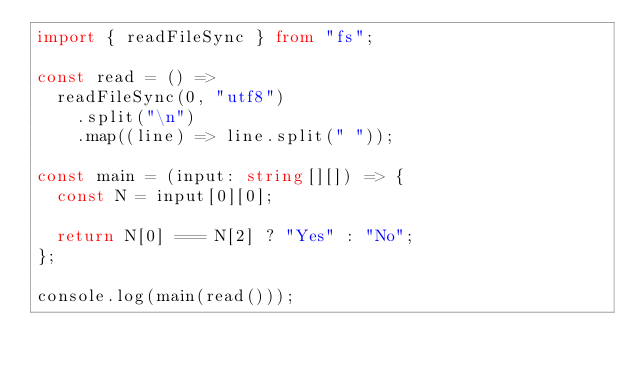Convert code to text. <code><loc_0><loc_0><loc_500><loc_500><_TypeScript_>import { readFileSync } from "fs";

const read = () =>
  readFileSync(0, "utf8")
    .split("\n")
    .map((line) => line.split(" "));

const main = (input: string[][]) => {
  const N = input[0][0];

  return N[0] === N[2] ? "Yes" : "No";
};

console.log(main(read()));
</code> 